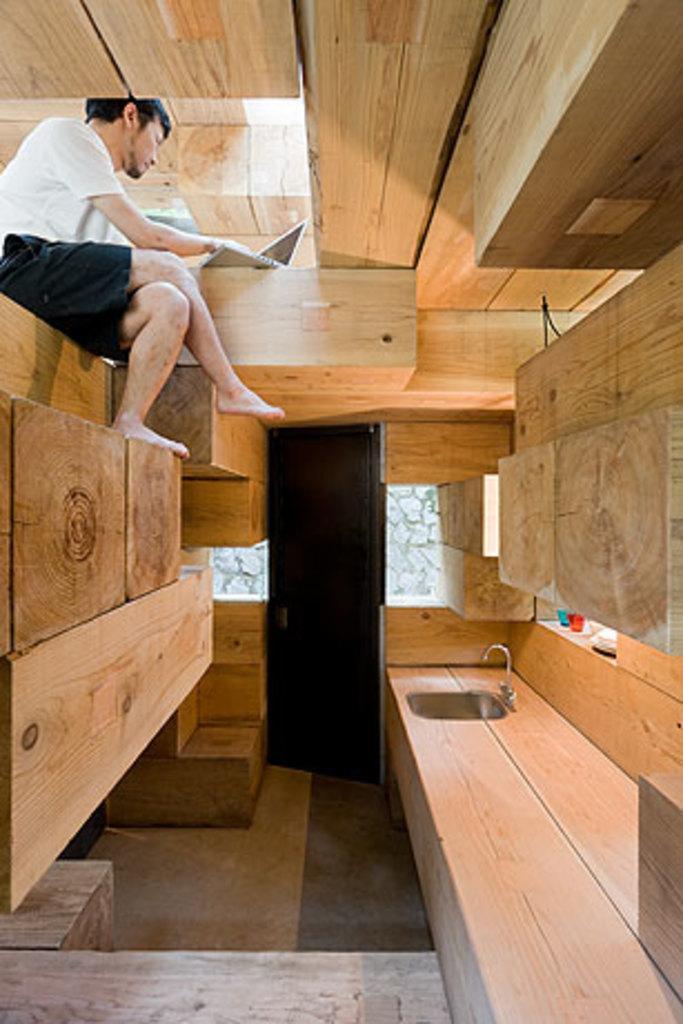Describe this image in one or two sentences. In this picture we can see a man, laptop, floor, door, sink, tap and wooden objects. 